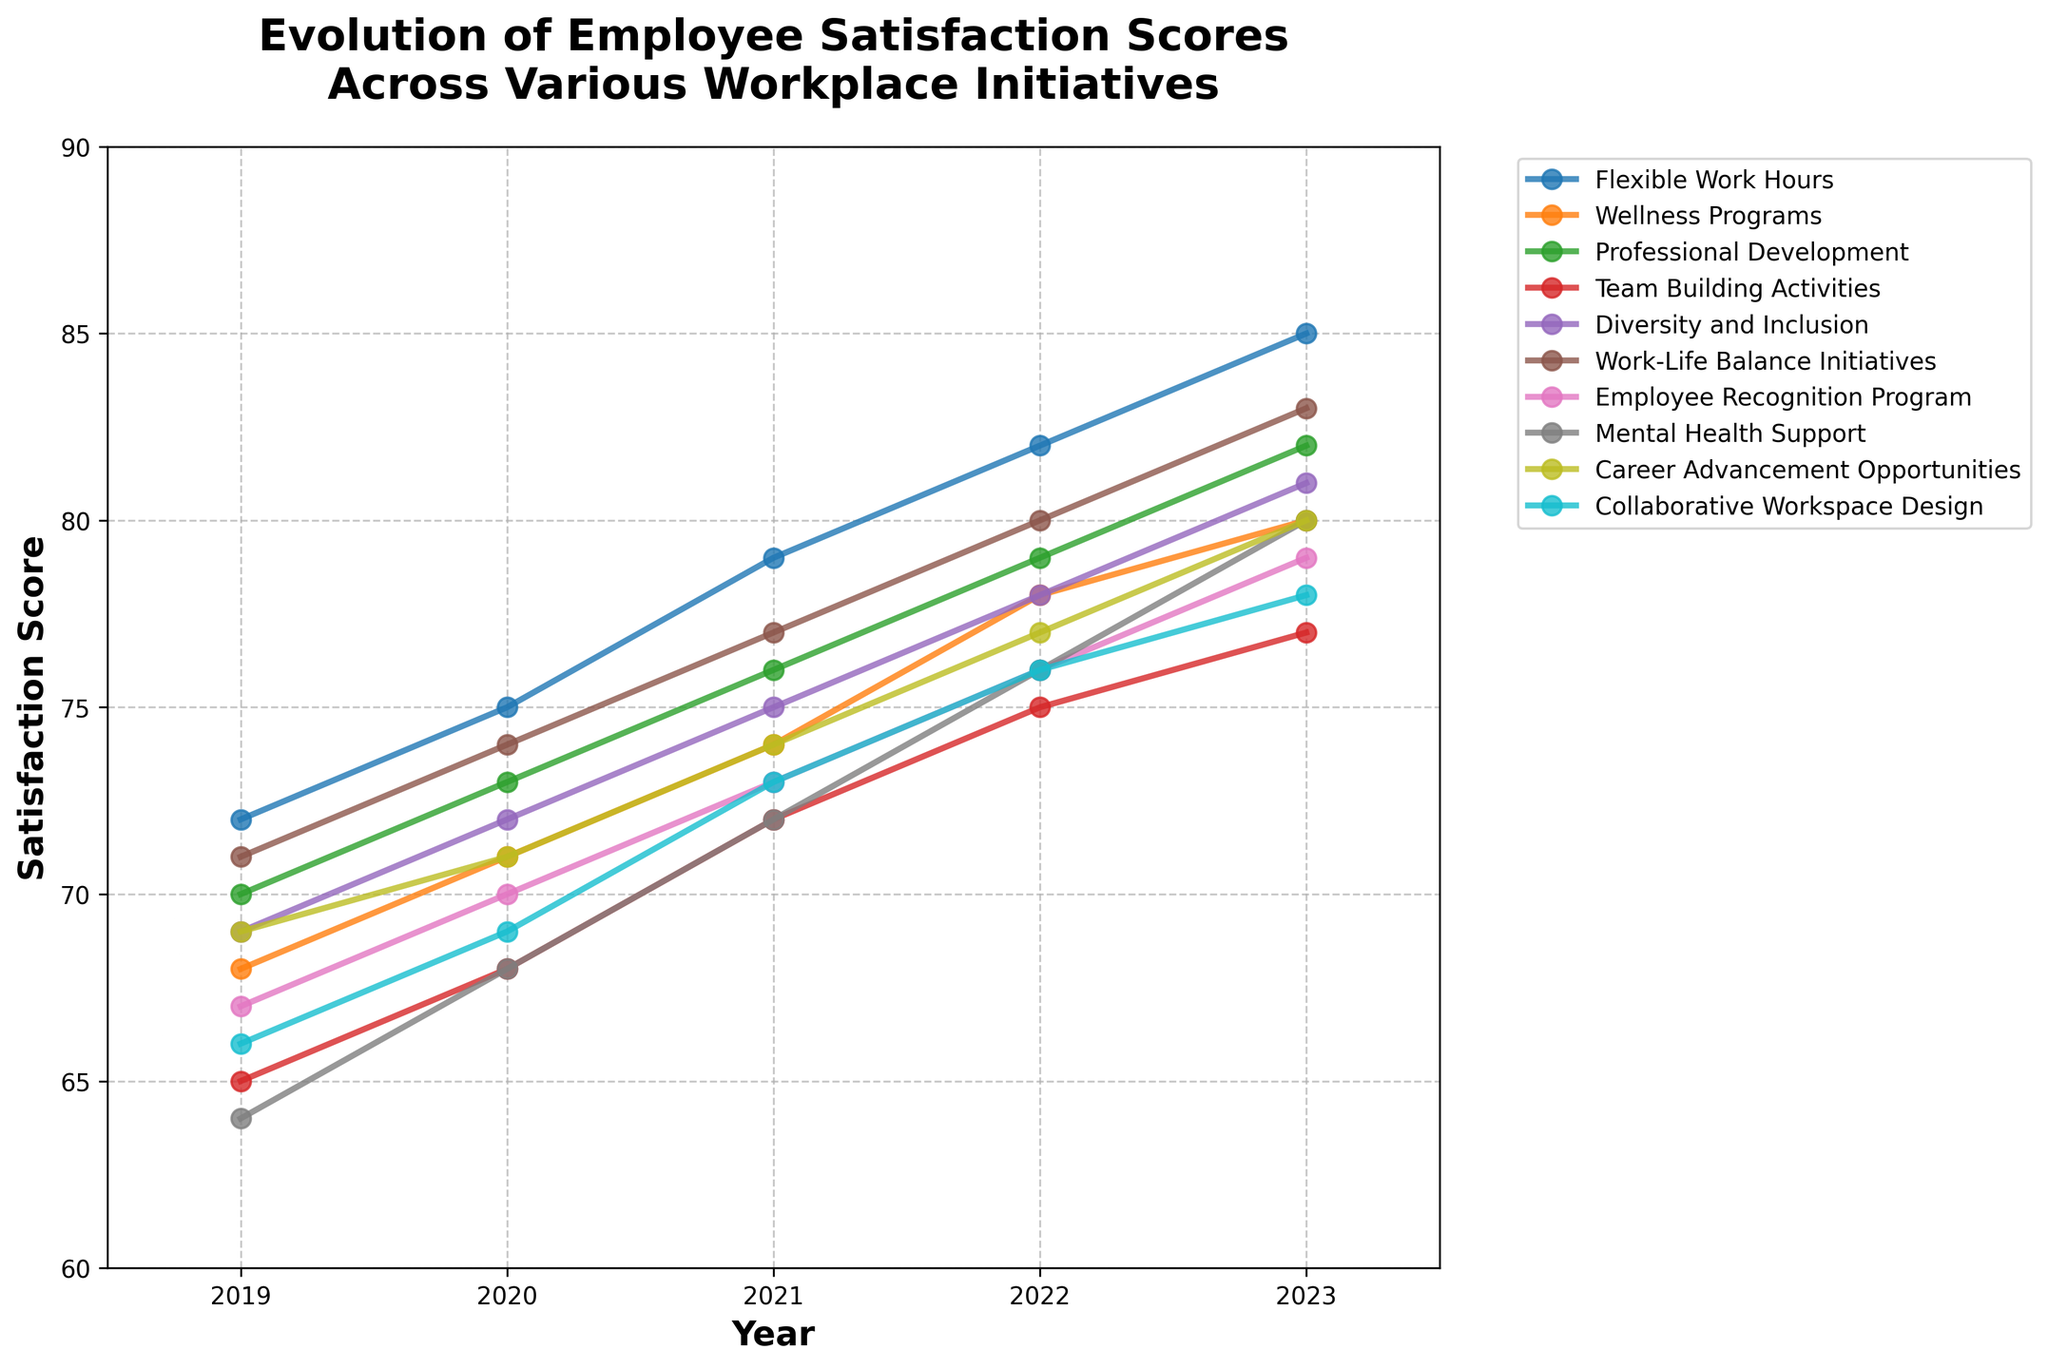Which initiative showed the largest increase in satisfaction score from 2019 to 2023? To find the largest increase, we need to calculate the score difference between 2019 and 2023 for each initiative. "Flexible Work Hours" increased by 13 (85-72), "Wellness Programs" by 12 (80-68), "Professional Development" by 12 (82-70), "Team Building Activities" by 12 (77-65), "Diversity and Inclusion" by 12 (81-69), "Work-Life Balance Initiatives" by 12 (83-71), "Employee Recognition Program" by 12 (79-67), "Mental Health Support" by 16 (80-64), "Career Advancement Opportunities" by 11 (80-69), and "Collaborative Workspace Design" by 12 (78-66). Hence, "Mental Health Support" showed the largest increase.
Answer: Mental Health Support Which year had the highest average satisfaction score across all initiatives? To find the average satisfaction score for each year, we sum the scores for all initiatives in that year and then divide by the number of initiatives. For 2019: (72 + 68 + 70 + 65 + 69 + 71 + 67 + 64 + 69 + 66) / 10 = 68.1. For 2020: (75 + 71 + 73 + 68 + 72 + 74 + 70 + 68 + 71 + 69) / 10 = 71.1. For 2021: (79 + 74 + 76 + 72 + 75 + 77 + 73 + 72 + 74 + 73) / 10 = 74.5. For 2022: (82 + 78 + 79 + 75 + 78 + 80 + 76 + 76 + 77 + 76) / 10 = 77.7. For 2023: (85 + 80 + 82 + 77 + 81 + 83 + 79 + 80 + 80 + 78) / 10 = 80.5. The highest average score is in 2023.
Answer: 2023 How do the satisfaction scores for "Flexible Work Hours" in 2023 compare to "Work-Life Balance Initiatives" in 2023? The satisfaction score for "Flexible Work Hours" in 2023 is 85, and for "Work-Life Balance Initiatives" in 2023, it is 83. Comparing these, "Flexible Work Hours" has a higher score.
Answer: Flexible Work Hours is higher Which initiative had the lowest satisfaction score in 2020? For 2020, the satisfaction scores for each initiative are reviewed: Flexible Work Hours (75), Wellness Programs (71), Professional Development (73), Team Building Activities (68), Diversity and Inclusion (72), Work-Life Balance Initiatives (74), Employee Recognition Program (70), Mental Health Support (68), Career Advancement Opportunities (71), Collaborative Workspace Design (69). The lowest satisfaction score is for "Team Building Activities" and "Mental Health Support", both at 68.
Answer: Team Building Activities and Mental Health Support What’s the average satisfaction score for "Professional Development" from 2019 to 2023? To find the average, sum the scores for each year and divide by the number of years. Scores are 70 (2019), 73 (2020), 76 (2021), 79 (2022), 82 (2023). The sum is 70 + 73 + 76 + 79 + 82 = 380. Dividing by 5 years, the average is 380 / 5 = 76.
Answer: 76 Between which two consecutive years did "Employee Recognition Program" see the largest increase in satisfaction score? Calculate the year-to-year differences: 2020-2019 = 70-67=3, 2021-2020 = 73-70=3, 2022-2021 = 76-73=3, 2023-2022 = 79-76=3. Since all differences are equal, the increase is the same between every pair of consecutive years. Therefore, the increase is consistent (3 points each year).
Answer: Consistent increase (3 points each year) How did the satisfaction score for "Diversity and Inclusion" change over the years? Looking at the scores: 69 (2019), 72 (2020), 75 (2021), 78 (2022), 81 (2023). The scores slightly increase every year by approximately 3 points.
Answer: Increased approximately 3 points each year 